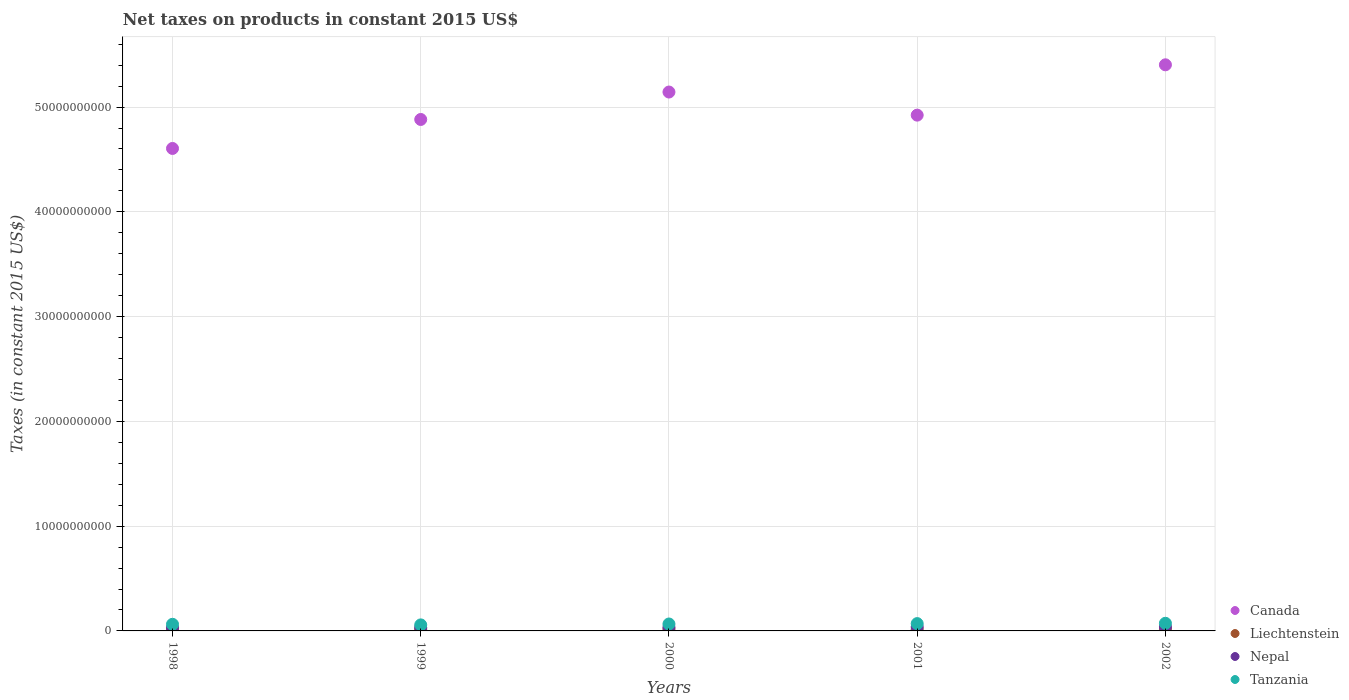What is the net taxes on products in Nepal in 2001?
Provide a succinct answer. 3.82e+08. Across all years, what is the maximum net taxes on products in Nepal?
Give a very brief answer. 3.83e+08. Across all years, what is the minimum net taxes on products in Canada?
Offer a terse response. 4.60e+1. In which year was the net taxes on products in Canada maximum?
Provide a succinct answer. 2002. In which year was the net taxes on products in Liechtenstein minimum?
Your response must be concise. 2001. What is the total net taxes on products in Liechtenstein in the graph?
Give a very brief answer. 8.01e+08. What is the difference between the net taxes on products in Canada in 2000 and that in 2001?
Your answer should be very brief. 2.20e+09. What is the difference between the net taxes on products in Liechtenstein in 2000 and the net taxes on products in Canada in 2001?
Provide a short and direct response. -4.91e+1. What is the average net taxes on products in Canada per year?
Make the answer very short. 4.99e+1. In the year 1999, what is the difference between the net taxes on products in Liechtenstein and net taxes on products in Nepal?
Offer a terse response. -1.42e+08. In how many years, is the net taxes on products in Liechtenstein greater than 18000000000 US$?
Give a very brief answer. 0. What is the ratio of the net taxes on products in Tanzania in 1999 to that in 2001?
Keep it short and to the point. 0.82. Is the net taxes on products in Tanzania in 1998 less than that in 2000?
Your response must be concise. Yes. Is the difference between the net taxes on products in Liechtenstein in 1998 and 2001 greater than the difference between the net taxes on products in Nepal in 1998 and 2001?
Provide a succinct answer. Yes. What is the difference between the highest and the second highest net taxes on products in Tanzania?
Make the answer very short. 3.06e+07. What is the difference between the highest and the lowest net taxes on products in Tanzania?
Ensure brevity in your answer.  1.53e+08. In how many years, is the net taxes on products in Tanzania greater than the average net taxes on products in Tanzania taken over all years?
Offer a very short reply. 3. Is it the case that in every year, the sum of the net taxes on products in Liechtenstein and net taxes on products in Tanzania  is greater than the net taxes on products in Canada?
Provide a short and direct response. No. Does the net taxes on products in Nepal monotonically increase over the years?
Make the answer very short. Yes. Is the net taxes on products in Canada strictly greater than the net taxes on products in Liechtenstein over the years?
Your answer should be very brief. Yes. How many dotlines are there?
Provide a succinct answer. 4. How many years are there in the graph?
Offer a very short reply. 5. What is the difference between two consecutive major ticks on the Y-axis?
Give a very brief answer. 1.00e+1. Are the values on the major ticks of Y-axis written in scientific E-notation?
Your response must be concise. No. Where does the legend appear in the graph?
Your answer should be compact. Bottom right. What is the title of the graph?
Your answer should be compact. Net taxes on products in constant 2015 US$. What is the label or title of the X-axis?
Give a very brief answer. Years. What is the label or title of the Y-axis?
Ensure brevity in your answer.  Taxes (in constant 2015 US$). What is the Taxes (in constant 2015 US$) of Canada in 1998?
Your answer should be compact. 4.60e+1. What is the Taxes (in constant 2015 US$) in Liechtenstein in 1998?
Provide a short and direct response. 1.54e+08. What is the Taxes (in constant 2015 US$) in Nepal in 1998?
Your answer should be compact. 3.06e+08. What is the Taxes (in constant 2015 US$) in Tanzania in 1998?
Your answer should be compact. 6.32e+08. What is the Taxes (in constant 2015 US$) in Canada in 1999?
Provide a short and direct response. 4.88e+1. What is the Taxes (in constant 2015 US$) in Liechtenstein in 1999?
Provide a short and direct response. 1.74e+08. What is the Taxes (in constant 2015 US$) in Nepal in 1999?
Your answer should be very brief. 3.16e+08. What is the Taxes (in constant 2015 US$) of Tanzania in 1999?
Make the answer very short. 5.75e+08. What is the Taxes (in constant 2015 US$) in Canada in 2000?
Provide a short and direct response. 5.14e+1. What is the Taxes (in constant 2015 US$) of Liechtenstein in 2000?
Your response must be concise. 1.64e+08. What is the Taxes (in constant 2015 US$) of Nepal in 2000?
Provide a succinct answer. 3.47e+08. What is the Taxes (in constant 2015 US$) of Tanzania in 2000?
Ensure brevity in your answer.  6.61e+08. What is the Taxes (in constant 2015 US$) of Canada in 2001?
Offer a very short reply. 4.92e+1. What is the Taxes (in constant 2015 US$) of Liechtenstein in 2001?
Ensure brevity in your answer.  1.39e+08. What is the Taxes (in constant 2015 US$) in Nepal in 2001?
Provide a succinct answer. 3.82e+08. What is the Taxes (in constant 2015 US$) of Tanzania in 2001?
Offer a terse response. 6.98e+08. What is the Taxes (in constant 2015 US$) of Canada in 2002?
Your answer should be compact. 5.40e+1. What is the Taxes (in constant 2015 US$) of Liechtenstein in 2002?
Offer a very short reply. 1.71e+08. What is the Taxes (in constant 2015 US$) of Nepal in 2002?
Provide a succinct answer. 3.83e+08. What is the Taxes (in constant 2015 US$) of Tanzania in 2002?
Ensure brevity in your answer.  7.29e+08. Across all years, what is the maximum Taxes (in constant 2015 US$) in Canada?
Your answer should be very brief. 5.40e+1. Across all years, what is the maximum Taxes (in constant 2015 US$) in Liechtenstein?
Make the answer very short. 1.74e+08. Across all years, what is the maximum Taxes (in constant 2015 US$) of Nepal?
Provide a succinct answer. 3.83e+08. Across all years, what is the maximum Taxes (in constant 2015 US$) of Tanzania?
Provide a succinct answer. 7.29e+08. Across all years, what is the minimum Taxes (in constant 2015 US$) of Canada?
Provide a short and direct response. 4.60e+1. Across all years, what is the minimum Taxes (in constant 2015 US$) in Liechtenstein?
Offer a very short reply. 1.39e+08. Across all years, what is the minimum Taxes (in constant 2015 US$) in Nepal?
Your response must be concise. 3.06e+08. Across all years, what is the minimum Taxes (in constant 2015 US$) of Tanzania?
Your answer should be very brief. 5.75e+08. What is the total Taxes (in constant 2015 US$) in Canada in the graph?
Offer a terse response. 2.50e+11. What is the total Taxes (in constant 2015 US$) in Liechtenstein in the graph?
Your answer should be very brief. 8.01e+08. What is the total Taxes (in constant 2015 US$) of Nepal in the graph?
Offer a very short reply. 1.73e+09. What is the total Taxes (in constant 2015 US$) of Tanzania in the graph?
Keep it short and to the point. 3.30e+09. What is the difference between the Taxes (in constant 2015 US$) of Canada in 1998 and that in 1999?
Ensure brevity in your answer.  -2.77e+09. What is the difference between the Taxes (in constant 2015 US$) in Liechtenstein in 1998 and that in 1999?
Keep it short and to the point. -2.02e+07. What is the difference between the Taxes (in constant 2015 US$) in Nepal in 1998 and that in 1999?
Provide a short and direct response. -9.98e+06. What is the difference between the Taxes (in constant 2015 US$) of Tanzania in 1998 and that in 1999?
Your answer should be very brief. 5.68e+07. What is the difference between the Taxes (in constant 2015 US$) of Canada in 1998 and that in 2000?
Provide a short and direct response. -5.39e+09. What is the difference between the Taxes (in constant 2015 US$) of Liechtenstein in 1998 and that in 2000?
Keep it short and to the point. -1.08e+07. What is the difference between the Taxes (in constant 2015 US$) in Nepal in 1998 and that in 2000?
Provide a succinct answer. -4.09e+07. What is the difference between the Taxes (in constant 2015 US$) in Tanzania in 1998 and that in 2000?
Provide a short and direct response. -2.88e+07. What is the difference between the Taxes (in constant 2015 US$) of Canada in 1998 and that in 2001?
Give a very brief answer. -3.18e+09. What is the difference between the Taxes (in constant 2015 US$) of Liechtenstein in 1998 and that in 2001?
Provide a short and direct response. 1.48e+07. What is the difference between the Taxes (in constant 2015 US$) of Nepal in 1998 and that in 2001?
Make the answer very short. -7.64e+07. What is the difference between the Taxes (in constant 2015 US$) of Tanzania in 1998 and that in 2001?
Offer a terse response. -6.60e+07. What is the difference between the Taxes (in constant 2015 US$) of Canada in 1998 and that in 2002?
Provide a short and direct response. -7.98e+09. What is the difference between the Taxes (in constant 2015 US$) in Liechtenstein in 1998 and that in 2002?
Your answer should be very brief. -1.70e+07. What is the difference between the Taxes (in constant 2015 US$) in Nepal in 1998 and that in 2002?
Your answer should be compact. -7.68e+07. What is the difference between the Taxes (in constant 2015 US$) of Tanzania in 1998 and that in 2002?
Give a very brief answer. -9.67e+07. What is the difference between the Taxes (in constant 2015 US$) in Canada in 1999 and that in 2000?
Offer a terse response. -2.62e+09. What is the difference between the Taxes (in constant 2015 US$) of Liechtenstein in 1999 and that in 2000?
Make the answer very short. 9.45e+06. What is the difference between the Taxes (in constant 2015 US$) in Nepal in 1999 and that in 2000?
Offer a terse response. -3.09e+07. What is the difference between the Taxes (in constant 2015 US$) of Tanzania in 1999 and that in 2000?
Make the answer very short. -8.56e+07. What is the difference between the Taxes (in constant 2015 US$) of Canada in 1999 and that in 2001?
Your answer should be compact. -4.14e+08. What is the difference between the Taxes (in constant 2015 US$) in Liechtenstein in 1999 and that in 2001?
Offer a terse response. 3.50e+07. What is the difference between the Taxes (in constant 2015 US$) of Nepal in 1999 and that in 2001?
Ensure brevity in your answer.  -6.64e+07. What is the difference between the Taxes (in constant 2015 US$) in Tanzania in 1999 and that in 2001?
Provide a short and direct response. -1.23e+08. What is the difference between the Taxes (in constant 2015 US$) of Canada in 1999 and that in 2002?
Offer a terse response. -5.22e+09. What is the difference between the Taxes (in constant 2015 US$) in Liechtenstein in 1999 and that in 2002?
Ensure brevity in your answer.  3.22e+06. What is the difference between the Taxes (in constant 2015 US$) of Nepal in 1999 and that in 2002?
Provide a succinct answer. -6.68e+07. What is the difference between the Taxes (in constant 2015 US$) of Tanzania in 1999 and that in 2002?
Keep it short and to the point. -1.53e+08. What is the difference between the Taxes (in constant 2015 US$) in Canada in 2000 and that in 2001?
Offer a terse response. 2.20e+09. What is the difference between the Taxes (in constant 2015 US$) of Liechtenstein in 2000 and that in 2001?
Give a very brief answer. 2.56e+07. What is the difference between the Taxes (in constant 2015 US$) in Nepal in 2000 and that in 2001?
Make the answer very short. -3.55e+07. What is the difference between the Taxes (in constant 2015 US$) of Tanzania in 2000 and that in 2001?
Offer a very short reply. -3.72e+07. What is the difference between the Taxes (in constant 2015 US$) of Canada in 2000 and that in 2002?
Provide a short and direct response. -2.60e+09. What is the difference between the Taxes (in constant 2015 US$) of Liechtenstein in 2000 and that in 2002?
Your answer should be compact. -6.23e+06. What is the difference between the Taxes (in constant 2015 US$) in Nepal in 2000 and that in 2002?
Keep it short and to the point. -3.59e+07. What is the difference between the Taxes (in constant 2015 US$) in Tanzania in 2000 and that in 2002?
Offer a terse response. -6.78e+07. What is the difference between the Taxes (in constant 2015 US$) in Canada in 2001 and that in 2002?
Make the answer very short. -4.80e+09. What is the difference between the Taxes (in constant 2015 US$) of Liechtenstein in 2001 and that in 2002?
Offer a very short reply. -3.18e+07. What is the difference between the Taxes (in constant 2015 US$) in Nepal in 2001 and that in 2002?
Provide a succinct answer. -3.46e+05. What is the difference between the Taxes (in constant 2015 US$) in Tanzania in 2001 and that in 2002?
Keep it short and to the point. -3.06e+07. What is the difference between the Taxes (in constant 2015 US$) in Canada in 1998 and the Taxes (in constant 2015 US$) in Liechtenstein in 1999?
Your answer should be very brief. 4.59e+1. What is the difference between the Taxes (in constant 2015 US$) in Canada in 1998 and the Taxes (in constant 2015 US$) in Nepal in 1999?
Offer a terse response. 4.57e+1. What is the difference between the Taxes (in constant 2015 US$) of Canada in 1998 and the Taxes (in constant 2015 US$) of Tanzania in 1999?
Ensure brevity in your answer.  4.55e+1. What is the difference between the Taxes (in constant 2015 US$) of Liechtenstein in 1998 and the Taxes (in constant 2015 US$) of Nepal in 1999?
Give a very brief answer. -1.62e+08. What is the difference between the Taxes (in constant 2015 US$) of Liechtenstein in 1998 and the Taxes (in constant 2015 US$) of Tanzania in 1999?
Provide a succinct answer. -4.22e+08. What is the difference between the Taxes (in constant 2015 US$) in Nepal in 1998 and the Taxes (in constant 2015 US$) in Tanzania in 1999?
Give a very brief answer. -2.70e+08. What is the difference between the Taxes (in constant 2015 US$) in Canada in 1998 and the Taxes (in constant 2015 US$) in Liechtenstein in 2000?
Keep it short and to the point. 4.59e+1. What is the difference between the Taxes (in constant 2015 US$) in Canada in 1998 and the Taxes (in constant 2015 US$) in Nepal in 2000?
Provide a succinct answer. 4.57e+1. What is the difference between the Taxes (in constant 2015 US$) in Canada in 1998 and the Taxes (in constant 2015 US$) in Tanzania in 2000?
Provide a succinct answer. 4.54e+1. What is the difference between the Taxes (in constant 2015 US$) in Liechtenstein in 1998 and the Taxes (in constant 2015 US$) in Nepal in 2000?
Your response must be concise. -1.93e+08. What is the difference between the Taxes (in constant 2015 US$) in Liechtenstein in 1998 and the Taxes (in constant 2015 US$) in Tanzania in 2000?
Ensure brevity in your answer.  -5.07e+08. What is the difference between the Taxes (in constant 2015 US$) in Nepal in 1998 and the Taxes (in constant 2015 US$) in Tanzania in 2000?
Offer a terse response. -3.55e+08. What is the difference between the Taxes (in constant 2015 US$) in Canada in 1998 and the Taxes (in constant 2015 US$) in Liechtenstein in 2001?
Your response must be concise. 4.59e+1. What is the difference between the Taxes (in constant 2015 US$) of Canada in 1998 and the Taxes (in constant 2015 US$) of Nepal in 2001?
Your answer should be very brief. 4.57e+1. What is the difference between the Taxes (in constant 2015 US$) of Canada in 1998 and the Taxes (in constant 2015 US$) of Tanzania in 2001?
Provide a short and direct response. 4.54e+1. What is the difference between the Taxes (in constant 2015 US$) of Liechtenstein in 1998 and the Taxes (in constant 2015 US$) of Nepal in 2001?
Keep it short and to the point. -2.29e+08. What is the difference between the Taxes (in constant 2015 US$) in Liechtenstein in 1998 and the Taxes (in constant 2015 US$) in Tanzania in 2001?
Provide a succinct answer. -5.45e+08. What is the difference between the Taxes (in constant 2015 US$) in Nepal in 1998 and the Taxes (in constant 2015 US$) in Tanzania in 2001?
Give a very brief answer. -3.93e+08. What is the difference between the Taxes (in constant 2015 US$) of Canada in 1998 and the Taxes (in constant 2015 US$) of Liechtenstein in 2002?
Ensure brevity in your answer.  4.59e+1. What is the difference between the Taxes (in constant 2015 US$) in Canada in 1998 and the Taxes (in constant 2015 US$) in Nepal in 2002?
Offer a very short reply. 4.57e+1. What is the difference between the Taxes (in constant 2015 US$) in Canada in 1998 and the Taxes (in constant 2015 US$) in Tanzania in 2002?
Offer a terse response. 4.53e+1. What is the difference between the Taxes (in constant 2015 US$) in Liechtenstein in 1998 and the Taxes (in constant 2015 US$) in Nepal in 2002?
Make the answer very short. -2.29e+08. What is the difference between the Taxes (in constant 2015 US$) of Liechtenstein in 1998 and the Taxes (in constant 2015 US$) of Tanzania in 2002?
Offer a terse response. -5.75e+08. What is the difference between the Taxes (in constant 2015 US$) of Nepal in 1998 and the Taxes (in constant 2015 US$) of Tanzania in 2002?
Offer a terse response. -4.23e+08. What is the difference between the Taxes (in constant 2015 US$) in Canada in 1999 and the Taxes (in constant 2015 US$) in Liechtenstein in 2000?
Keep it short and to the point. 4.87e+1. What is the difference between the Taxes (in constant 2015 US$) in Canada in 1999 and the Taxes (in constant 2015 US$) in Nepal in 2000?
Make the answer very short. 4.85e+1. What is the difference between the Taxes (in constant 2015 US$) in Canada in 1999 and the Taxes (in constant 2015 US$) in Tanzania in 2000?
Your answer should be compact. 4.82e+1. What is the difference between the Taxes (in constant 2015 US$) in Liechtenstein in 1999 and the Taxes (in constant 2015 US$) in Nepal in 2000?
Provide a short and direct response. -1.73e+08. What is the difference between the Taxes (in constant 2015 US$) of Liechtenstein in 1999 and the Taxes (in constant 2015 US$) of Tanzania in 2000?
Provide a succinct answer. -4.87e+08. What is the difference between the Taxes (in constant 2015 US$) in Nepal in 1999 and the Taxes (in constant 2015 US$) in Tanzania in 2000?
Provide a succinct answer. -3.45e+08. What is the difference between the Taxes (in constant 2015 US$) of Canada in 1999 and the Taxes (in constant 2015 US$) of Liechtenstein in 2001?
Provide a short and direct response. 4.87e+1. What is the difference between the Taxes (in constant 2015 US$) in Canada in 1999 and the Taxes (in constant 2015 US$) in Nepal in 2001?
Provide a short and direct response. 4.84e+1. What is the difference between the Taxes (in constant 2015 US$) in Canada in 1999 and the Taxes (in constant 2015 US$) in Tanzania in 2001?
Your answer should be very brief. 4.81e+1. What is the difference between the Taxes (in constant 2015 US$) of Liechtenstein in 1999 and the Taxes (in constant 2015 US$) of Nepal in 2001?
Your response must be concise. -2.08e+08. What is the difference between the Taxes (in constant 2015 US$) in Liechtenstein in 1999 and the Taxes (in constant 2015 US$) in Tanzania in 2001?
Offer a terse response. -5.24e+08. What is the difference between the Taxes (in constant 2015 US$) in Nepal in 1999 and the Taxes (in constant 2015 US$) in Tanzania in 2001?
Offer a very short reply. -3.83e+08. What is the difference between the Taxes (in constant 2015 US$) of Canada in 1999 and the Taxes (in constant 2015 US$) of Liechtenstein in 2002?
Provide a short and direct response. 4.86e+1. What is the difference between the Taxes (in constant 2015 US$) of Canada in 1999 and the Taxes (in constant 2015 US$) of Nepal in 2002?
Offer a very short reply. 4.84e+1. What is the difference between the Taxes (in constant 2015 US$) in Canada in 1999 and the Taxes (in constant 2015 US$) in Tanzania in 2002?
Offer a very short reply. 4.81e+1. What is the difference between the Taxes (in constant 2015 US$) of Liechtenstein in 1999 and the Taxes (in constant 2015 US$) of Nepal in 2002?
Keep it short and to the point. -2.09e+08. What is the difference between the Taxes (in constant 2015 US$) of Liechtenstein in 1999 and the Taxes (in constant 2015 US$) of Tanzania in 2002?
Your answer should be compact. -5.55e+08. What is the difference between the Taxes (in constant 2015 US$) in Nepal in 1999 and the Taxes (in constant 2015 US$) in Tanzania in 2002?
Ensure brevity in your answer.  -4.13e+08. What is the difference between the Taxes (in constant 2015 US$) of Canada in 2000 and the Taxes (in constant 2015 US$) of Liechtenstein in 2001?
Your answer should be very brief. 5.13e+1. What is the difference between the Taxes (in constant 2015 US$) of Canada in 2000 and the Taxes (in constant 2015 US$) of Nepal in 2001?
Offer a terse response. 5.11e+1. What is the difference between the Taxes (in constant 2015 US$) of Canada in 2000 and the Taxes (in constant 2015 US$) of Tanzania in 2001?
Your answer should be very brief. 5.07e+1. What is the difference between the Taxes (in constant 2015 US$) in Liechtenstein in 2000 and the Taxes (in constant 2015 US$) in Nepal in 2001?
Offer a very short reply. -2.18e+08. What is the difference between the Taxes (in constant 2015 US$) in Liechtenstein in 2000 and the Taxes (in constant 2015 US$) in Tanzania in 2001?
Make the answer very short. -5.34e+08. What is the difference between the Taxes (in constant 2015 US$) in Nepal in 2000 and the Taxes (in constant 2015 US$) in Tanzania in 2001?
Ensure brevity in your answer.  -3.52e+08. What is the difference between the Taxes (in constant 2015 US$) in Canada in 2000 and the Taxes (in constant 2015 US$) in Liechtenstein in 2002?
Provide a short and direct response. 5.13e+1. What is the difference between the Taxes (in constant 2015 US$) in Canada in 2000 and the Taxes (in constant 2015 US$) in Nepal in 2002?
Provide a succinct answer. 5.11e+1. What is the difference between the Taxes (in constant 2015 US$) in Canada in 2000 and the Taxes (in constant 2015 US$) in Tanzania in 2002?
Your answer should be very brief. 5.07e+1. What is the difference between the Taxes (in constant 2015 US$) of Liechtenstein in 2000 and the Taxes (in constant 2015 US$) of Nepal in 2002?
Provide a short and direct response. -2.18e+08. What is the difference between the Taxes (in constant 2015 US$) in Liechtenstein in 2000 and the Taxes (in constant 2015 US$) in Tanzania in 2002?
Make the answer very short. -5.65e+08. What is the difference between the Taxes (in constant 2015 US$) in Nepal in 2000 and the Taxes (in constant 2015 US$) in Tanzania in 2002?
Ensure brevity in your answer.  -3.82e+08. What is the difference between the Taxes (in constant 2015 US$) of Canada in 2001 and the Taxes (in constant 2015 US$) of Liechtenstein in 2002?
Provide a short and direct response. 4.91e+1. What is the difference between the Taxes (in constant 2015 US$) in Canada in 2001 and the Taxes (in constant 2015 US$) in Nepal in 2002?
Offer a terse response. 4.88e+1. What is the difference between the Taxes (in constant 2015 US$) of Canada in 2001 and the Taxes (in constant 2015 US$) of Tanzania in 2002?
Provide a short and direct response. 4.85e+1. What is the difference between the Taxes (in constant 2015 US$) of Liechtenstein in 2001 and the Taxes (in constant 2015 US$) of Nepal in 2002?
Your response must be concise. -2.44e+08. What is the difference between the Taxes (in constant 2015 US$) in Liechtenstein in 2001 and the Taxes (in constant 2015 US$) in Tanzania in 2002?
Your answer should be compact. -5.90e+08. What is the difference between the Taxes (in constant 2015 US$) in Nepal in 2001 and the Taxes (in constant 2015 US$) in Tanzania in 2002?
Make the answer very short. -3.47e+08. What is the average Taxes (in constant 2015 US$) of Canada per year?
Make the answer very short. 4.99e+1. What is the average Taxes (in constant 2015 US$) of Liechtenstein per year?
Provide a succinct answer. 1.60e+08. What is the average Taxes (in constant 2015 US$) of Nepal per year?
Your answer should be compact. 3.47e+08. What is the average Taxes (in constant 2015 US$) of Tanzania per year?
Offer a terse response. 6.59e+08. In the year 1998, what is the difference between the Taxes (in constant 2015 US$) of Canada and Taxes (in constant 2015 US$) of Liechtenstein?
Provide a short and direct response. 4.59e+1. In the year 1998, what is the difference between the Taxes (in constant 2015 US$) of Canada and Taxes (in constant 2015 US$) of Nepal?
Your answer should be very brief. 4.57e+1. In the year 1998, what is the difference between the Taxes (in constant 2015 US$) of Canada and Taxes (in constant 2015 US$) of Tanzania?
Ensure brevity in your answer.  4.54e+1. In the year 1998, what is the difference between the Taxes (in constant 2015 US$) of Liechtenstein and Taxes (in constant 2015 US$) of Nepal?
Provide a succinct answer. -1.52e+08. In the year 1998, what is the difference between the Taxes (in constant 2015 US$) of Liechtenstein and Taxes (in constant 2015 US$) of Tanzania?
Ensure brevity in your answer.  -4.79e+08. In the year 1998, what is the difference between the Taxes (in constant 2015 US$) in Nepal and Taxes (in constant 2015 US$) in Tanzania?
Your answer should be compact. -3.26e+08. In the year 1999, what is the difference between the Taxes (in constant 2015 US$) of Canada and Taxes (in constant 2015 US$) of Liechtenstein?
Your answer should be compact. 4.86e+1. In the year 1999, what is the difference between the Taxes (in constant 2015 US$) in Canada and Taxes (in constant 2015 US$) in Nepal?
Make the answer very short. 4.85e+1. In the year 1999, what is the difference between the Taxes (in constant 2015 US$) of Canada and Taxes (in constant 2015 US$) of Tanzania?
Your answer should be very brief. 4.82e+1. In the year 1999, what is the difference between the Taxes (in constant 2015 US$) of Liechtenstein and Taxes (in constant 2015 US$) of Nepal?
Give a very brief answer. -1.42e+08. In the year 1999, what is the difference between the Taxes (in constant 2015 US$) in Liechtenstein and Taxes (in constant 2015 US$) in Tanzania?
Make the answer very short. -4.02e+08. In the year 1999, what is the difference between the Taxes (in constant 2015 US$) of Nepal and Taxes (in constant 2015 US$) of Tanzania?
Give a very brief answer. -2.60e+08. In the year 2000, what is the difference between the Taxes (in constant 2015 US$) in Canada and Taxes (in constant 2015 US$) in Liechtenstein?
Your answer should be very brief. 5.13e+1. In the year 2000, what is the difference between the Taxes (in constant 2015 US$) in Canada and Taxes (in constant 2015 US$) in Nepal?
Ensure brevity in your answer.  5.11e+1. In the year 2000, what is the difference between the Taxes (in constant 2015 US$) in Canada and Taxes (in constant 2015 US$) in Tanzania?
Your answer should be very brief. 5.08e+1. In the year 2000, what is the difference between the Taxes (in constant 2015 US$) in Liechtenstein and Taxes (in constant 2015 US$) in Nepal?
Make the answer very short. -1.82e+08. In the year 2000, what is the difference between the Taxes (in constant 2015 US$) in Liechtenstein and Taxes (in constant 2015 US$) in Tanzania?
Offer a very short reply. -4.97e+08. In the year 2000, what is the difference between the Taxes (in constant 2015 US$) in Nepal and Taxes (in constant 2015 US$) in Tanzania?
Offer a very short reply. -3.14e+08. In the year 2001, what is the difference between the Taxes (in constant 2015 US$) in Canada and Taxes (in constant 2015 US$) in Liechtenstein?
Provide a short and direct response. 4.91e+1. In the year 2001, what is the difference between the Taxes (in constant 2015 US$) in Canada and Taxes (in constant 2015 US$) in Nepal?
Give a very brief answer. 4.88e+1. In the year 2001, what is the difference between the Taxes (in constant 2015 US$) of Canada and Taxes (in constant 2015 US$) of Tanzania?
Offer a terse response. 4.85e+1. In the year 2001, what is the difference between the Taxes (in constant 2015 US$) in Liechtenstein and Taxes (in constant 2015 US$) in Nepal?
Provide a short and direct response. -2.43e+08. In the year 2001, what is the difference between the Taxes (in constant 2015 US$) of Liechtenstein and Taxes (in constant 2015 US$) of Tanzania?
Keep it short and to the point. -5.59e+08. In the year 2001, what is the difference between the Taxes (in constant 2015 US$) in Nepal and Taxes (in constant 2015 US$) in Tanzania?
Your answer should be very brief. -3.16e+08. In the year 2002, what is the difference between the Taxes (in constant 2015 US$) of Canada and Taxes (in constant 2015 US$) of Liechtenstein?
Your response must be concise. 5.39e+1. In the year 2002, what is the difference between the Taxes (in constant 2015 US$) in Canada and Taxes (in constant 2015 US$) in Nepal?
Provide a short and direct response. 5.37e+1. In the year 2002, what is the difference between the Taxes (in constant 2015 US$) of Canada and Taxes (in constant 2015 US$) of Tanzania?
Offer a very short reply. 5.33e+1. In the year 2002, what is the difference between the Taxes (in constant 2015 US$) in Liechtenstein and Taxes (in constant 2015 US$) in Nepal?
Offer a very short reply. -2.12e+08. In the year 2002, what is the difference between the Taxes (in constant 2015 US$) of Liechtenstein and Taxes (in constant 2015 US$) of Tanzania?
Your answer should be very brief. -5.58e+08. In the year 2002, what is the difference between the Taxes (in constant 2015 US$) of Nepal and Taxes (in constant 2015 US$) of Tanzania?
Ensure brevity in your answer.  -3.46e+08. What is the ratio of the Taxes (in constant 2015 US$) in Canada in 1998 to that in 1999?
Your response must be concise. 0.94. What is the ratio of the Taxes (in constant 2015 US$) of Liechtenstein in 1998 to that in 1999?
Make the answer very short. 0.88. What is the ratio of the Taxes (in constant 2015 US$) of Nepal in 1998 to that in 1999?
Your answer should be compact. 0.97. What is the ratio of the Taxes (in constant 2015 US$) in Tanzania in 1998 to that in 1999?
Keep it short and to the point. 1.1. What is the ratio of the Taxes (in constant 2015 US$) of Canada in 1998 to that in 2000?
Offer a terse response. 0.9. What is the ratio of the Taxes (in constant 2015 US$) in Liechtenstein in 1998 to that in 2000?
Make the answer very short. 0.93. What is the ratio of the Taxes (in constant 2015 US$) in Nepal in 1998 to that in 2000?
Keep it short and to the point. 0.88. What is the ratio of the Taxes (in constant 2015 US$) in Tanzania in 1998 to that in 2000?
Make the answer very short. 0.96. What is the ratio of the Taxes (in constant 2015 US$) in Canada in 1998 to that in 2001?
Keep it short and to the point. 0.94. What is the ratio of the Taxes (in constant 2015 US$) of Liechtenstein in 1998 to that in 2001?
Provide a short and direct response. 1.11. What is the ratio of the Taxes (in constant 2015 US$) of Nepal in 1998 to that in 2001?
Offer a terse response. 0.8. What is the ratio of the Taxes (in constant 2015 US$) of Tanzania in 1998 to that in 2001?
Provide a succinct answer. 0.91. What is the ratio of the Taxes (in constant 2015 US$) in Canada in 1998 to that in 2002?
Your response must be concise. 0.85. What is the ratio of the Taxes (in constant 2015 US$) in Liechtenstein in 1998 to that in 2002?
Offer a very short reply. 0.9. What is the ratio of the Taxes (in constant 2015 US$) in Nepal in 1998 to that in 2002?
Your answer should be compact. 0.8. What is the ratio of the Taxes (in constant 2015 US$) of Tanzania in 1998 to that in 2002?
Provide a succinct answer. 0.87. What is the ratio of the Taxes (in constant 2015 US$) in Canada in 1999 to that in 2000?
Offer a terse response. 0.95. What is the ratio of the Taxes (in constant 2015 US$) in Liechtenstein in 1999 to that in 2000?
Provide a short and direct response. 1.06. What is the ratio of the Taxes (in constant 2015 US$) of Nepal in 1999 to that in 2000?
Ensure brevity in your answer.  0.91. What is the ratio of the Taxes (in constant 2015 US$) in Tanzania in 1999 to that in 2000?
Keep it short and to the point. 0.87. What is the ratio of the Taxes (in constant 2015 US$) in Canada in 1999 to that in 2001?
Provide a short and direct response. 0.99. What is the ratio of the Taxes (in constant 2015 US$) in Liechtenstein in 1999 to that in 2001?
Your response must be concise. 1.25. What is the ratio of the Taxes (in constant 2015 US$) of Nepal in 1999 to that in 2001?
Your answer should be very brief. 0.83. What is the ratio of the Taxes (in constant 2015 US$) of Tanzania in 1999 to that in 2001?
Keep it short and to the point. 0.82. What is the ratio of the Taxes (in constant 2015 US$) of Canada in 1999 to that in 2002?
Offer a terse response. 0.9. What is the ratio of the Taxes (in constant 2015 US$) in Liechtenstein in 1999 to that in 2002?
Offer a terse response. 1.02. What is the ratio of the Taxes (in constant 2015 US$) of Nepal in 1999 to that in 2002?
Provide a short and direct response. 0.83. What is the ratio of the Taxes (in constant 2015 US$) of Tanzania in 1999 to that in 2002?
Ensure brevity in your answer.  0.79. What is the ratio of the Taxes (in constant 2015 US$) in Canada in 2000 to that in 2001?
Provide a short and direct response. 1.04. What is the ratio of the Taxes (in constant 2015 US$) of Liechtenstein in 2000 to that in 2001?
Your response must be concise. 1.18. What is the ratio of the Taxes (in constant 2015 US$) in Nepal in 2000 to that in 2001?
Give a very brief answer. 0.91. What is the ratio of the Taxes (in constant 2015 US$) of Tanzania in 2000 to that in 2001?
Your answer should be very brief. 0.95. What is the ratio of the Taxes (in constant 2015 US$) of Canada in 2000 to that in 2002?
Provide a succinct answer. 0.95. What is the ratio of the Taxes (in constant 2015 US$) in Liechtenstein in 2000 to that in 2002?
Provide a short and direct response. 0.96. What is the ratio of the Taxes (in constant 2015 US$) of Nepal in 2000 to that in 2002?
Your answer should be compact. 0.91. What is the ratio of the Taxes (in constant 2015 US$) in Tanzania in 2000 to that in 2002?
Give a very brief answer. 0.91. What is the ratio of the Taxes (in constant 2015 US$) in Canada in 2001 to that in 2002?
Make the answer very short. 0.91. What is the ratio of the Taxes (in constant 2015 US$) of Liechtenstein in 2001 to that in 2002?
Make the answer very short. 0.81. What is the ratio of the Taxes (in constant 2015 US$) in Tanzania in 2001 to that in 2002?
Your response must be concise. 0.96. What is the difference between the highest and the second highest Taxes (in constant 2015 US$) of Canada?
Provide a succinct answer. 2.60e+09. What is the difference between the highest and the second highest Taxes (in constant 2015 US$) of Liechtenstein?
Your answer should be compact. 3.22e+06. What is the difference between the highest and the second highest Taxes (in constant 2015 US$) of Nepal?
Ensure brevity in your answer.  3.46e+05. What is the difference between the highest and the second highest Taxes (in constant 2015 US$) of Tanzania?
Your answer should be compact. 3.06e+07. What is the difference between the highest and the lowest Taxes (in constant 2015 US$) in Canada?
Your answer should be compact. 7.98e+09. What is the difference between the highest and the lowest Taxes (in constant 2015 US$) of Liechtenstein?
Your answer should be compact. 3.50e+07. What is the difference between the highest and the lowest Taxes (in constant 2015 US$) of Nepal?
Your answer should be very brief. 7.68e+07. What is the difference between the highest and the lowest Taxes (in constant 2015 US$) in Tanzania?
Offer a terse response. 1.53e+08. 